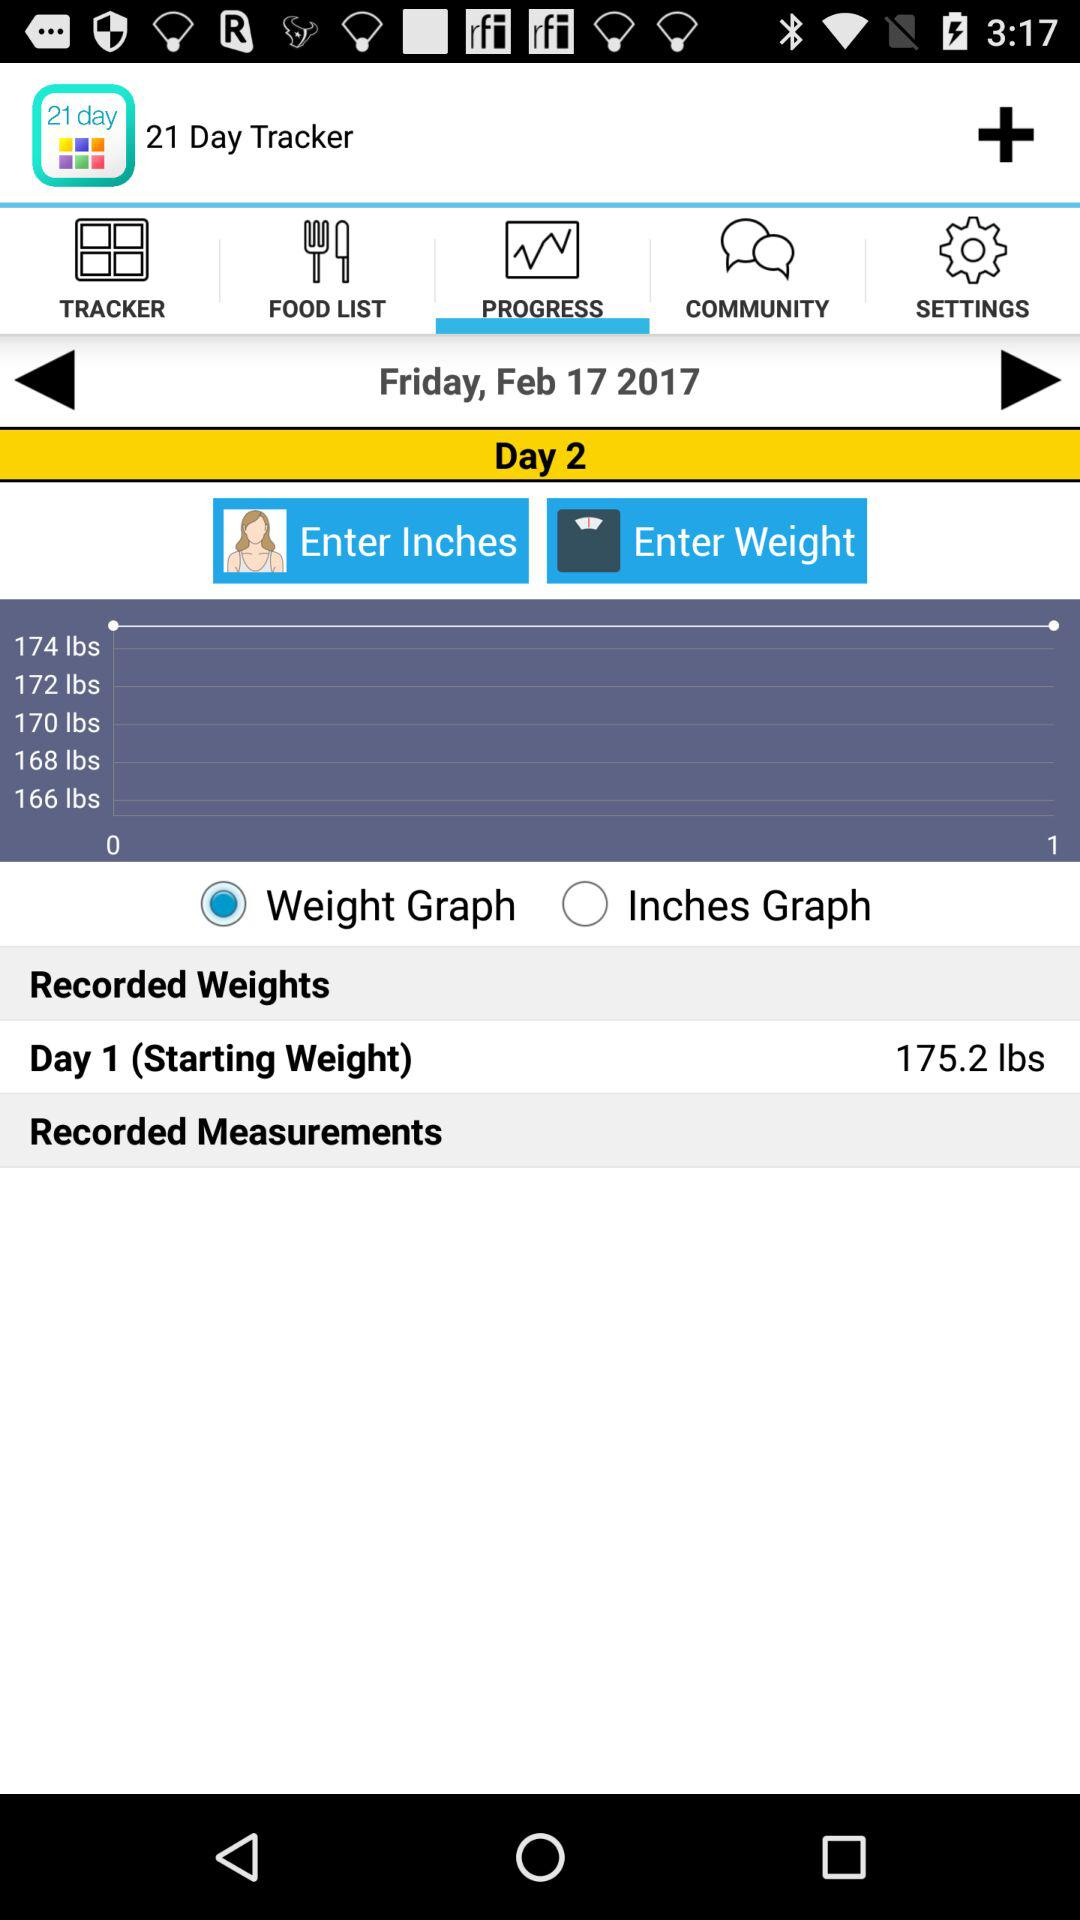Which tab is selected? The selected tab is "PROGRESS". 